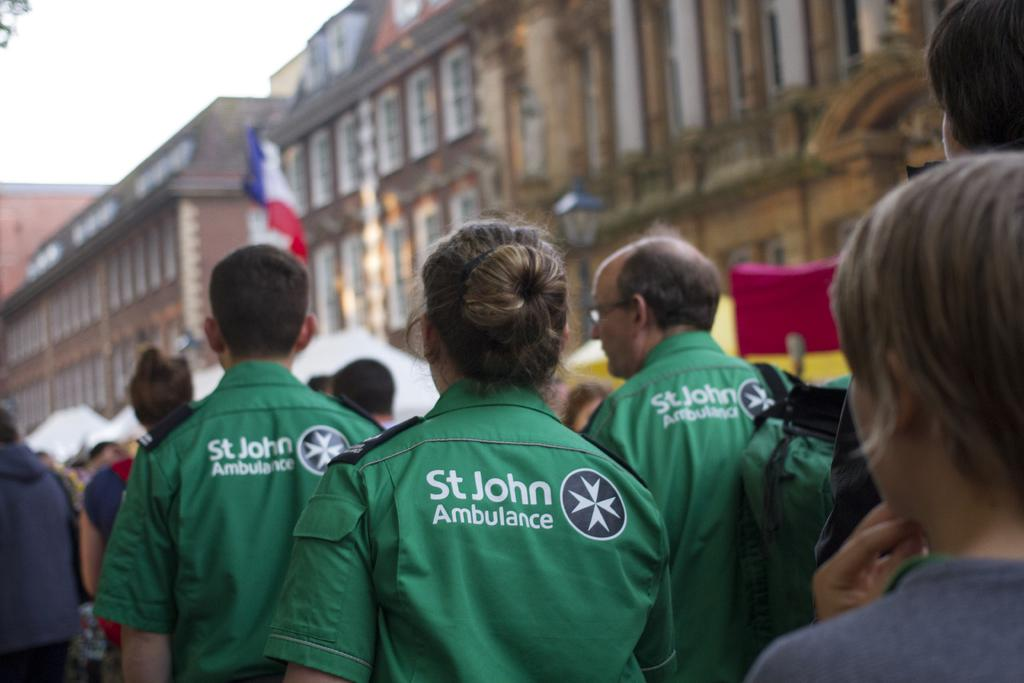How many people are present in the image? There are many people in the image. What can be seen in the background of the image? There is a building with windows and the sky is visible in the background. Is there any symbol or emblem present in the image? Yes, there is a flag in the image. What type of sweater is the person in the image wearing? There is no person wearing a sweater in the image. How does the flag turn in the image? The flag does not turn in the image; it is stationary. 